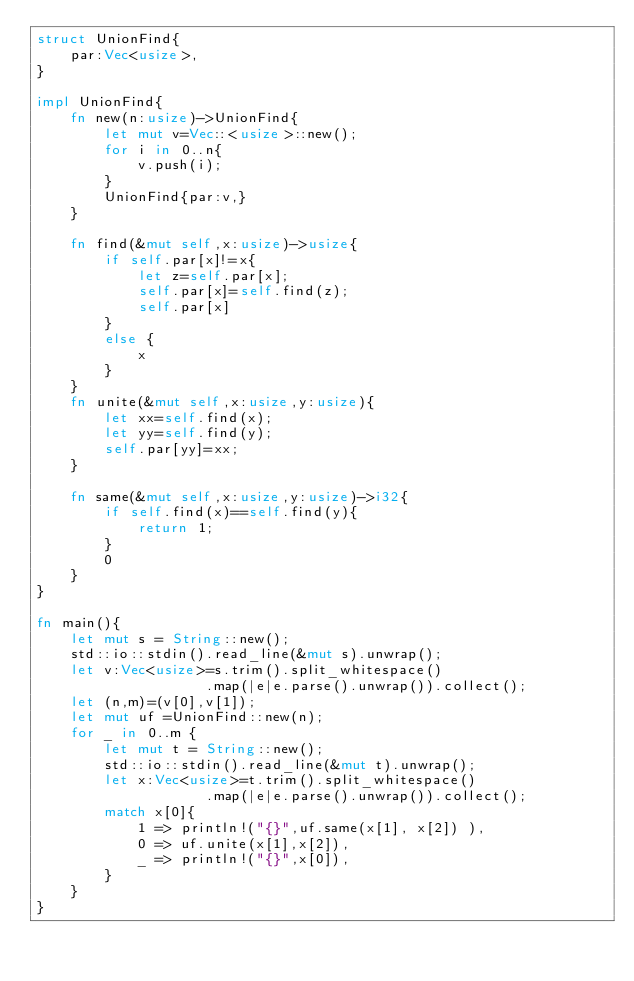Convert code to text. <code><loc_0><loc_0><loc_500><loc_500><_Rust_>struct UnionFind{
    par:Vec<usize>,
}

impl UnionFind{
    fn new(n:usize)->UnionFind{
        let mut v=Vec::<usize>::new();
        for i in 0..n{
            v.push(i);
        }
        UnionFind{par:v,}
    }

    fn find(&mut self,x:usize)->usize{
        if self.par[x]!=x{
            let z=self.par[x];
            self.par[x]=self.find(z);
            self.par[x]
        }
        else {
            x
        }
    }
    fn unite(&mut self,x:usize,y:usize){
        let xx=self.find(x);
        let yy=self.find(y);
        self.par[yy]=xx;
    }

    fn same(&mut self,x:usize,y:usize)->i32{
        if self.find(x)==self.find(y){
            return 1;
        }
        0
    }
}

fn main(){
    let mut s = String::new();
    std::io::stdin().read_line(&mut s).unwrap();
    let v:Vec<usize>=s.trim().split_whitespace()
                    .map(|e|e.parse().unwrap()).collect();
    let (n,m)=(v[0],v[1]);
    let mut uf =UnionFind::new(n);
    for _ in 0..m {
        let mut t = String::new();
        std::io::stdin().read_line(&mut t).unwrap();
        let x:Vec<usize>=t.trim().split_whitespace()
                    .map(|e|e.parse().unwrap()).collect();
        match x[0]{
            1 => println!("{}",uf.same(x[1], x[2]) ),
            0 => uf.unite(x[1],x[2]),
            _ => println!("{}",x[0]),
        }
    }
}
</code> 